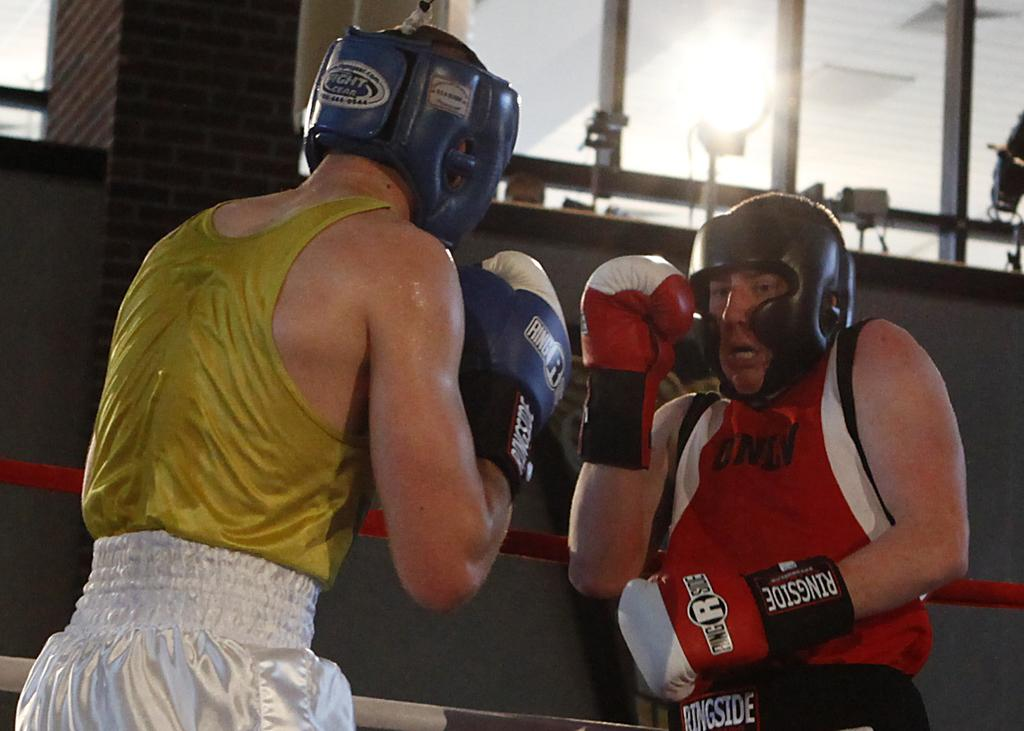<image>
Describe the image concisely. Two boxers with Ring Side gloves square off in a battle. 